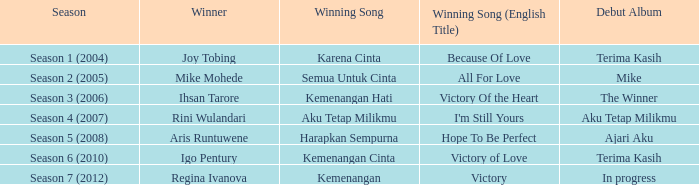Which victorious track was part of an in-progress debut album? Kemenangan. 